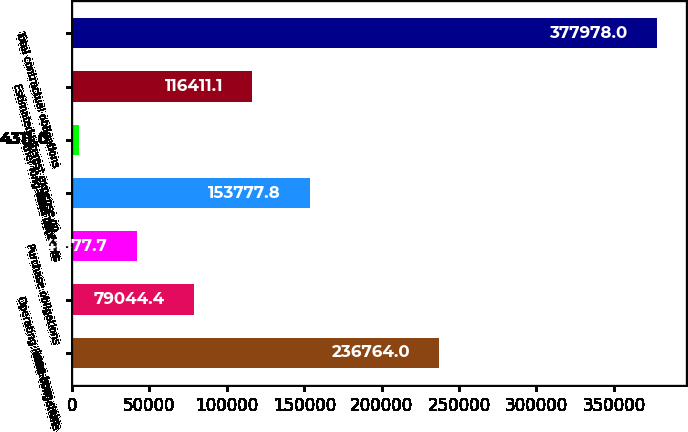Convert chart. <chart><loc_0><loc_0><loc_500><loc_500><bar_chart><fcel>Long-term debt<fcel>Operating lease obligations<fcel>Purchase obligations<fcel>Time deposits<fcel>Other long-term liabilities<fcel>Estimated interest expense on<fcel>Total contractual obligations<nl><fcel>236764<fcel>79044.4<fcel>41677.7<fcel>153778<fcel>4311<fcel>116411<fcel>377978<nl></chart> 